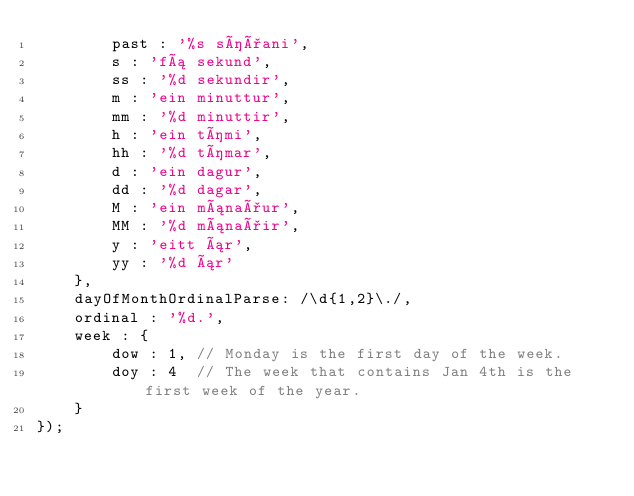<code> <loc_0><loc_0><loc_500><loc_500><_JavaScript_>        past : '%s síðani',
        s : 'fá sekund',
        ss : '%d sekundir',
        m : 'ein minuttur',
        mm : '%d minuttir',
        h : 'ein tími',
        hh : '%d tímar',
        d : 'ein dagur',
        dd : '%d dagar',
        M : 'ein mánaður',
        MM : '%d mánaðir',
        y : 'eitt ár',
        yy : '%d ár'
    },
    dayOfMonthOrdinalParse: /\d{1,2}\./,
    ordinal : '%d.',
    week : {
        dow : 1, // Monday is the first day of the week.
        doy : 4  // The week that contains Jan 4th is the first week of the year.
    }
});

</code> 